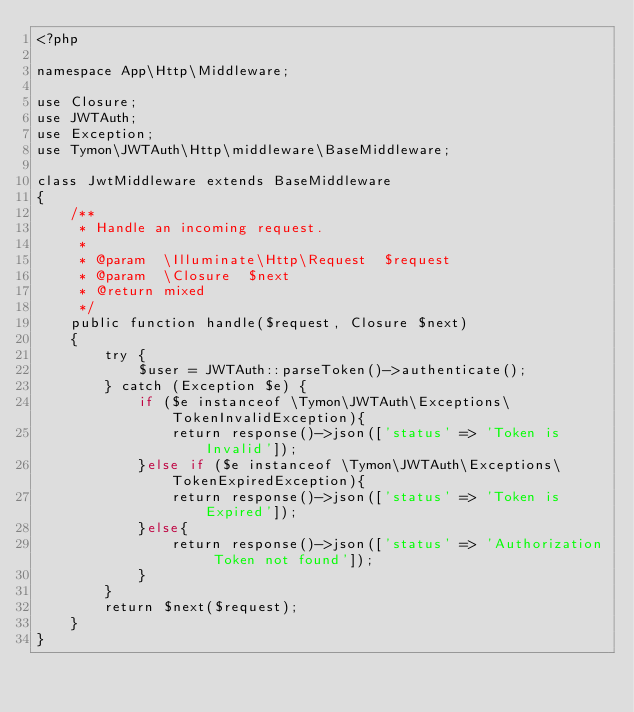<code> <loc_0><loc_0><loc_500><loc_500><_PHP_><?php

namespace App\Http\Middleware;

use Closure;
use JWTAuth;
use Exception;
use Tymon\JWTAuth\Http\middleware\BaseMiddleware;

class JwtMiddleware extends BaseMiddleware
{
    /**
     * Handle an incoming request.
     *
     * @param  \Illuminate\Http\Request  $request
     * @param  \Closure  $next
     * @return mixed
     */
    public function handle($request, Closure $next)
    {
        try {
            $user = JWTAuth::parseToken()->authenticate();
        } catch (Exception $e) {
            if ($e instanceof \Tymon\JWTAuth\Exceptions\TokenInvalidException){
                return response()->json(['status' => 'Token is Invalid']);
            }else if ($e instanceof \Tymon\JWTAuth\Exceptions\TokenExpiredException){
                return response()->json(['status' => 'Token is Expired']);
            }else{
                return response()->json(['status' => 'Authorization Token not found']);
            }
        }
        return $next($request);
    }
}
</code> 